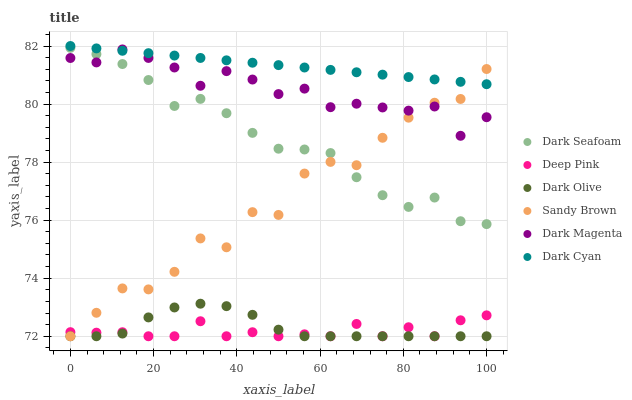Does Deep Pink have the minimum area under the curve?
Answer yes or no. Yes. Does Dark Cyan have the maximum area under the curve?
Answer yes or no. Yes. Does Dark Magenta have the minimum area under the curve?
Answer yes or no. No. Does Dark Magenta have the maximum area under the curve?
Answer yes or no. No. Is Dark Cyan the smoothest?
Answer yes or no. Yes. Is Sandy Brown the roughest?
Answer yes or no. Yes. Is Dark Magenta the smoothest?
Answer yes or no. No. Is Dark Magenta the roughest?
Answer yes or no. No. Does Deep Pink have the lowest value?
Answer yes or no. Yes. Does Dark Magenta have the lowest value?
Answer yes or no. No. Does Dark Cyan have the highest value?
Answer yes or no. Yes. Does Dark Magenta have the highest value?
Answer yes or no. No. Is Dark Seafoam less than Dark Cyan?
Answer yes or no. Yes. Is Dark Cyan greater than Dark Seafoam?
Answer yes or no. Yes. Does Dark Magenta intersect Sandy Brown?
Answer yes or no. Yes. Is Dark Magenta less than Sandy Brown?
Answer yes or no. No. Is Dark Magenta greater than Sandy Brown?
Answer yes or no. No. Does Dark Seafoam intersect Dark Cyan?
Answer yes or no. No. 